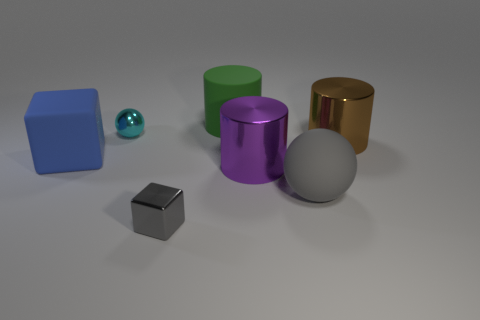Is the large brown metallic object the same shape as the purple thing?
Provide a short and direct response. Yes. What size is the matte thing on the left side of the sphere that is behind the rubber thing on the left side of the metal ball?
Your response must be concise. Large. Are there any small balls behind the big metal thing that is in front of the brown cylinder?
Offer a terse response. Yes. There is a ball that is to the right of the big rubber thing that is behind the small cyan sphere; what number of big shiny objects are left of it?
Provide a succinct answer. 1. There is a shiny object that is both behind the big gray rubber thing and to the left of the green cylinder; what is its color?
Offer a terse response. Cyan. What number of spheres have the same color as the small metal cube?
Offer a very short reply. 1. How many cylinders are either cyan things or large green rubber things?
Your answer should be compact. 1. The matte sphere that is the same size as the green cylinder is what color?
Your response must be concise. Gray. Is there a big cylinder in front of the large matte object that is left of the tiny metallic object that is behind the large brown metal object?
Ensure brevity in your answer.  Yes. How big is the brown cylinder?
Offer a very short reply. Large. 